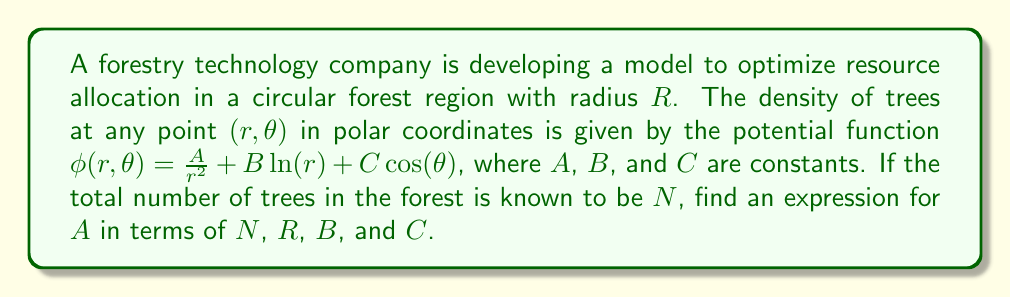What is the answer to this math problem? To solve this problem, we'll follow these steps:

1) The total number of trees $N$ is given by the double integral of the density function over the entire forest area:

   $$N = \int_0^{2\pi} \int_0^R \phi(r,\theta) r dr d\theta$$

2) Substitute the given potential function:

   $$N = \int_0^{2\pi} \int_0^R \left(\frac{A}{r^2} + B\ln(r) + C\cos(\theta)\right) r dr d\theta$$

3) Simplify the integrand:

   $$N = \int_0^{2\pi} \int_0^R \left(\frac{A}{r} + Br\ln(r) + Cr\cos(\theta)\right) dr d\theta$$

4) Evaluate the inner integral with respect to $r$:

   $$N = \int_0^{2\pi} \left[A\ln(r) + \frac{1}{2}Br^2(\ln(r)-\frac{1}{2}) + Cr^2\cos(\theta)\right]_0^R d\theta$$

5) Substitute the limits:

   $$N = \int_0^{2\pi} \left(A\ln(R) + \frac{1}{2}BR^2(\ln(R)-\frac{1}{2}) + CR^2\cos(\theta)\right) d\theta$$

6) Evaluate the outer integral with respect to $\theta$:

   $$N = 2\pi A\ln(R) + \pi BR^2(\ln(R)-\frac{1}{2}) + CR^2\int_0^{2\pi} \cos(\theta) d\theta$$

7) The integral of cosine over a full period is zero:

   $$N = 2\pi A\ln(R) + \pi BR^2(\ln(R)-\frac{1}{2})$$

8) Solve for $A$:

   $$A = \frac{N - \pi BR^2(\ln(R)-\frac{1}{2})}{2\pi \ln(R)}$$
Answer: $$A = \frac{N - \pi BR^2(\ln(R)-\frac{1}{2})}{2\pi \ln(R)}$$ 